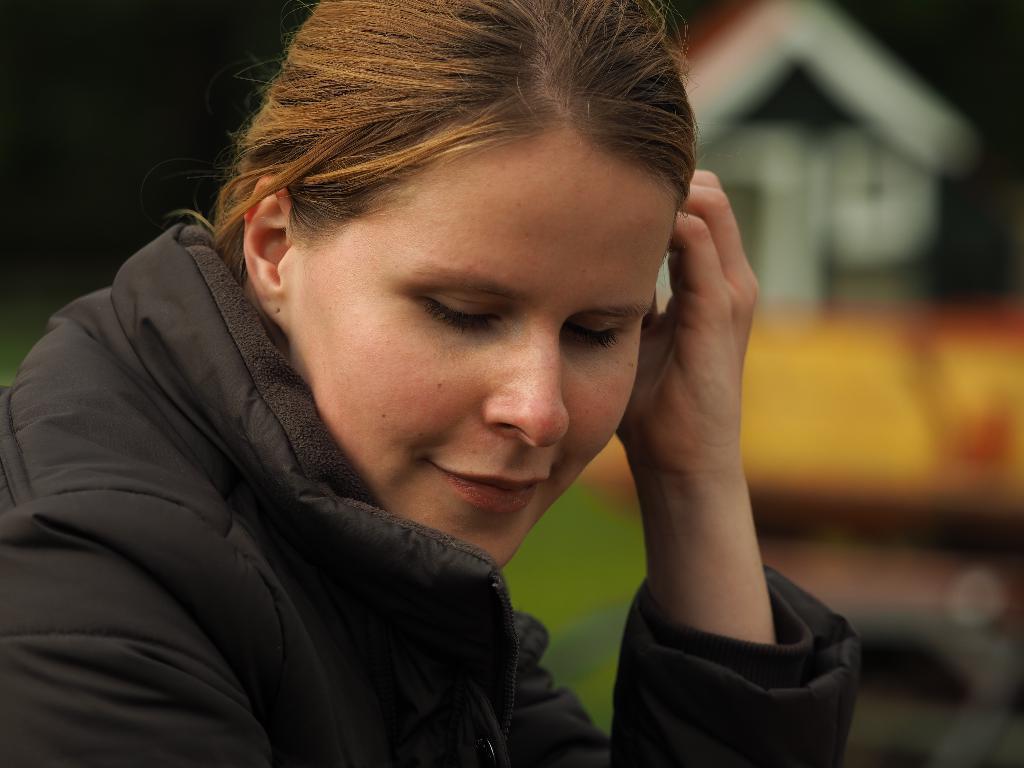Could you give a brief overview of what you see in this image? In the image there is a woman in golden hair and black jacket in the front and in the back it seems to be home on the right side. 